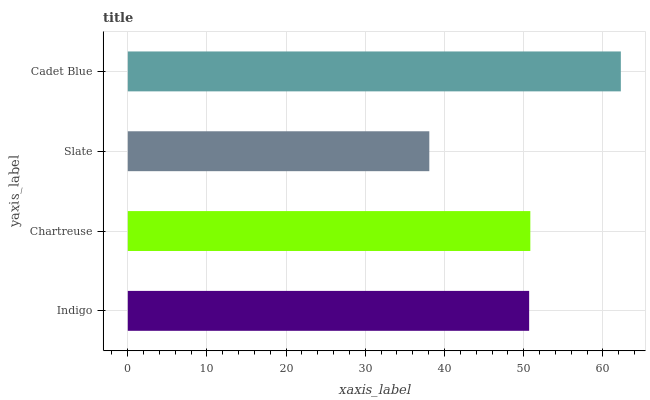Is Slate the minimum?
Answer yes or no. Yes. Is Cadet Blue the maximum?
Answer yes or no. Yes. Is Chartreuse the minimum?
Answer yes or no. No. Is Chartreuse the maximum?
Answer yes or no. No. Is Chartreuse greater than Indigo?
Answer yes or no. Yes. Is Indigo less than Chartreuse?
Answer yes or no. Yes. Is Indigo greater than Chartreuse?
Answer yes or no. No. Is Chartreuse less than Indigo?
Answer yes or no. No. Is Chartreuse the high median?
Answer yes or no. Yes. Is Indigo the low median?
Answer yes or no. Yes. Is Indigo the high median?
Answer yes or no. No. Is Cadet Blue the low median?
Answer yes or no. No. 